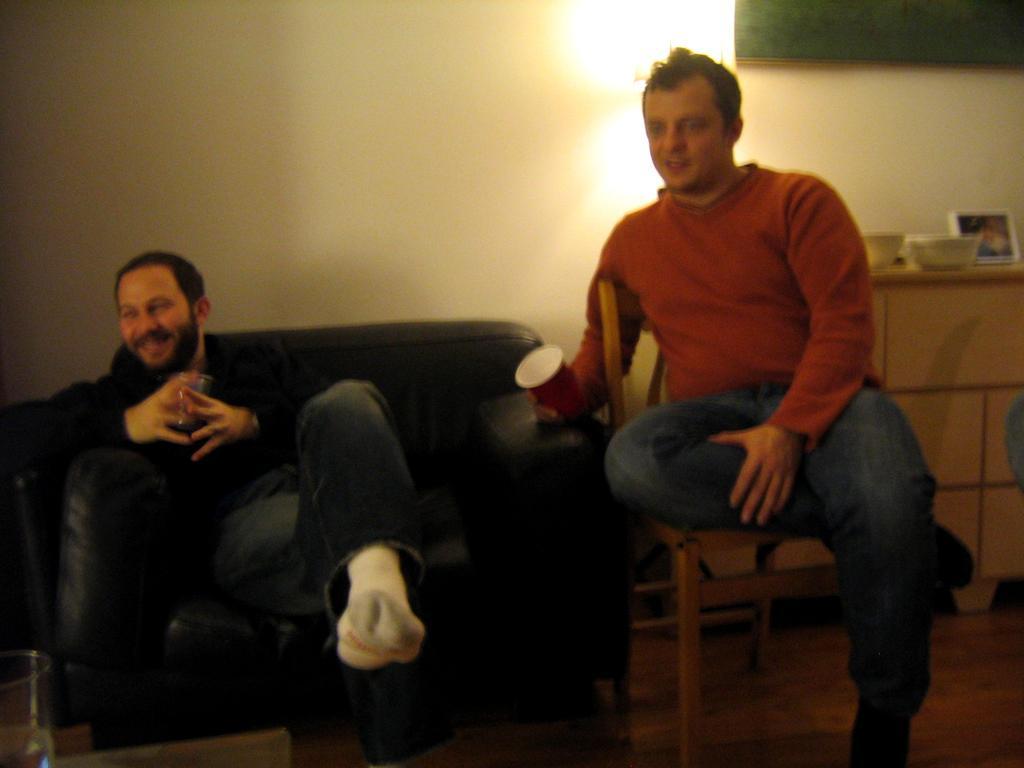In one or two sentences, can you explain what this image depicts? In this image there is a man sitting in the couch holding a glass,another man sitting in the chair holding the glass at the back ground there is a wall , cupboard , a frame ,bowl,cup. 